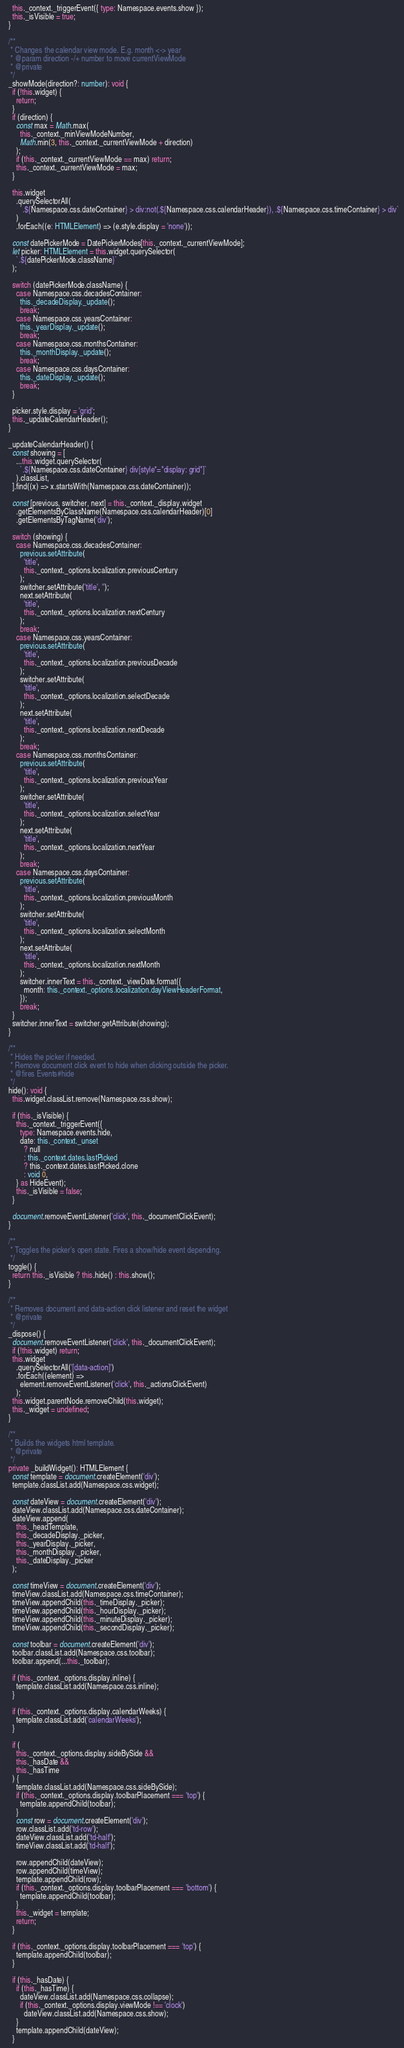<code> <loc_0><loc_0><loc_500><loc_500><_TypeScript_>    this._context._triggerEvent({ type: Namespace.events.show });
    this._isVisible = true;
  }

  /**
   * Changes the calendar view mode. E.g. month <-> year
   * @param direction -/+ number to move currentViewMode
   * @private
   */
  _showMode(direction?: number): void {
    if (!this.widget) {
      return;
    }
    if (direction) {
      const max = Math.max(
        this._context._minViewModeNumber,
        Math.min(3, this._context._currentViewMode + direction)
      );
      if (this._context._currentViewMode == max) return;
      this._context._currentViewMode = max;
    }

    this.widget
      .querySelectorAll(
        `.${Namespace.css.dateContainer} > div:not(.${Namespace.css.calendarHeader}), .${Namespace.css.timeContainer} > div`
      )
      .forEach((e: HTMLElement) => (e.style.display = 'none'));

    const datePickerMode = DatePickerModes[this._context._currentViewMode];
    let picker: HTMLElement = this.widget.querySelector(
      `.${datePickerMode.className}`
    );

    switch (datePickerMode.className) {
      case Namespace.css.decadesContainer:
        this._decadeDisplay._update();
        break;
      case Namespace.css.yearsContainer:
        this._yearDisplay._update();
        break;
      case Namespace.css.monthsContainer:
        this._monthDisplay._update();
        break;
      case Namespace.css.daysContainer:
        this._dateDisplay._update();
        break;
    }

    picker.style.display = 'grid';
    this._updateCalendarHeader();
  }

  _updateCalendarHeader() {
    const showing = [
      ...this.widget.querySelector(
        `.${Namespace.css.dateContainer} div[style*="display: grid"]`
      ).classList,
    ].find((x) => x.startsWith(Namespace.css.dateContainer));

    const [previous, switcher, next] = this._context._display.widget
      .getElementsByClassName(Namespace.css.calendarHeader)[0]
      .getElementsByTagName('div');

    switch (showing) {
      case Namespace.css.decadesContainer:
        previous.setAttribute(
          'title',
          this._context._options.localization.previousCentury
        );
        switcher.setAttribute('title', '');
        next.setAttribute(
          'title',
          this._context._options.localization.nextCentury
        );
        break;
      case Namespace.css.yearsContainer:
        previous.setAttribute(
          'title',
          this._context._options.localization.previousDecade
        );
        switcher.setAttribute(
          'title',
          this._context._options.localization.selectDecade
        );
        next.setAttribute(
          'title',
          this._context._options.localization.nextDecade
        );
        break;
      case Namespace.css.monthsContainer:
        previous.setAttribute(
          'title',
          this._context._options.localization.previousYear
        );
        switcher.setAttribute(
          'title',
          this._context._options.localization.selectYear
        );
        next.setAttribute(
          'title',
          this._context._options.localization.nextYear
        );
        break;
      case Namespace.css.daysContainer:
        previous.setAttribute(
          'title',
          this._context._options.localization.previousMonth
        );
        switcher.setAttribute(
          'title',
          this._context._options.localization.selectMonth
        );
        next.setAttribute(
          'title',
          this._context._options.localization.nextMonth
        );
        switcher.innerText = this._context._viewDate.format({
          month: this._context._options.localization.dayViewHeaderFormat,
        });
        break;
    }
    switcher.innerText = switcher.getAttribute(showing);
  }

  /**
   * Hides the picker if needed.
   * Remove document click event to hide when clicking outside the picker.
   * @fires Events#hide
   */
  hide(): void {
    this.widget.classList.remove(Namespace.css.show);

    if (this._isVisible) {
      this._context._triggerEvent({
        type: Namespace.events.hide,
        date: this._context._unset
          ? null
          : this._context.dates.lastPicked
          ? this._context.dates.lastPicked.clone
          : void 0,
      } as HideEvent);
      this._isVisible = false;
    }

    document.removeEventListener('click', this._documentClickEvent);
  }

  /**
   * Toggles the picker's open state. Fires a show/hide event depending.
   */
  toggle() {
    return this._isVisible ? this.hide() : this.show();
  }

  /**
   * Removes document and data-action click listener and reset the widget
   * @private
   */
  _dispose() {
    document.removeEventListener('click', this._documentClickEvent);
    if (!this.widget) return;
    this.widget
      .querySelectorAll('[data-action]')
      .forEach((element) =>
        element.removeEventListener('click', this._actionsClickEvent)
      );
    this.widget.parentNode.removeChild(this.widget);
    this._widget = undefined;
  }

  /**
   * Builds the widgets html template.
   * @private
   */
  private _buildWidget(): HTMLElement {
    const template = document.createElement('div');
    template.classList.add(Namespace.css.widget);

    const dateView = document.createElement('div');
    dateView.classList.add(Namespace.css.dateContainer);
    dateView.append(
      this._headTemplate,
      this._decadeDisplay._picker,
      this._yearDisplay._picker,
      this._monthDisplay._picker,
      this._dateDisplay._picker
    );

    const timeView = document.createElement('div');
    timeView.classList.add(Namespace.css.timeContainer);
    timeView.appendChild(this._timeDisplay._picker);
    timeView.appendChild(this._hourDisplay._picker);
    timeView.appendChild(this._minuteDisplay._picker);
    timeView.appendChild(this._secondDisplay._picker);

    const toolbar = document.createElement('div');
    toolbar.classList.add(Namespace.css.toolbar);
    toolbar.append(...this._toolbar);

    if (this._context._options.display.inline) {
      template.classList.add(Namespace.css.inline);
    }

    if (this._context._options.display.calendarWeeks) {
      template.classList.add('calendarWeeks');
    }

    if (
      this._context._options.display.sideBySide &&
      this._hasDate &&
      this._hasTime
    ) {
      template.classList.add(Namespace.css.sideBySide);
      if (this._context._options.display.toolbarPlacement === 'top') {
        template.appendChild(toolbar);
      }
      const row = document.createElement('div');
      row.classList.add('td-row');
      dateView.classList.add('td-half');
      timeView.classList.add('td-half');

      row.appendChild(dateView);
      row.appendChild(timeView);
      template.appendChild(row);
      if (this._context._options.display.toolbarPlacement === 'bottom') {
        template.appendChild(toolbar);
      }
      this._widget = template;
      return;
    }

    if (this._context._options.display.toolbarPlacement === 'top') {
      template.appendChild(toolbar);
    }

    if (this._hasDate) {
      if (this._hasTime) {
        dateView.classList.add(Namespace.css.collapse);
        if (this._context._options.display.viewMode !== 'clock')
          dateView.classList.add(Namespace.css.show);
      }
      template.appendChild(dateView);
    }
</code> 